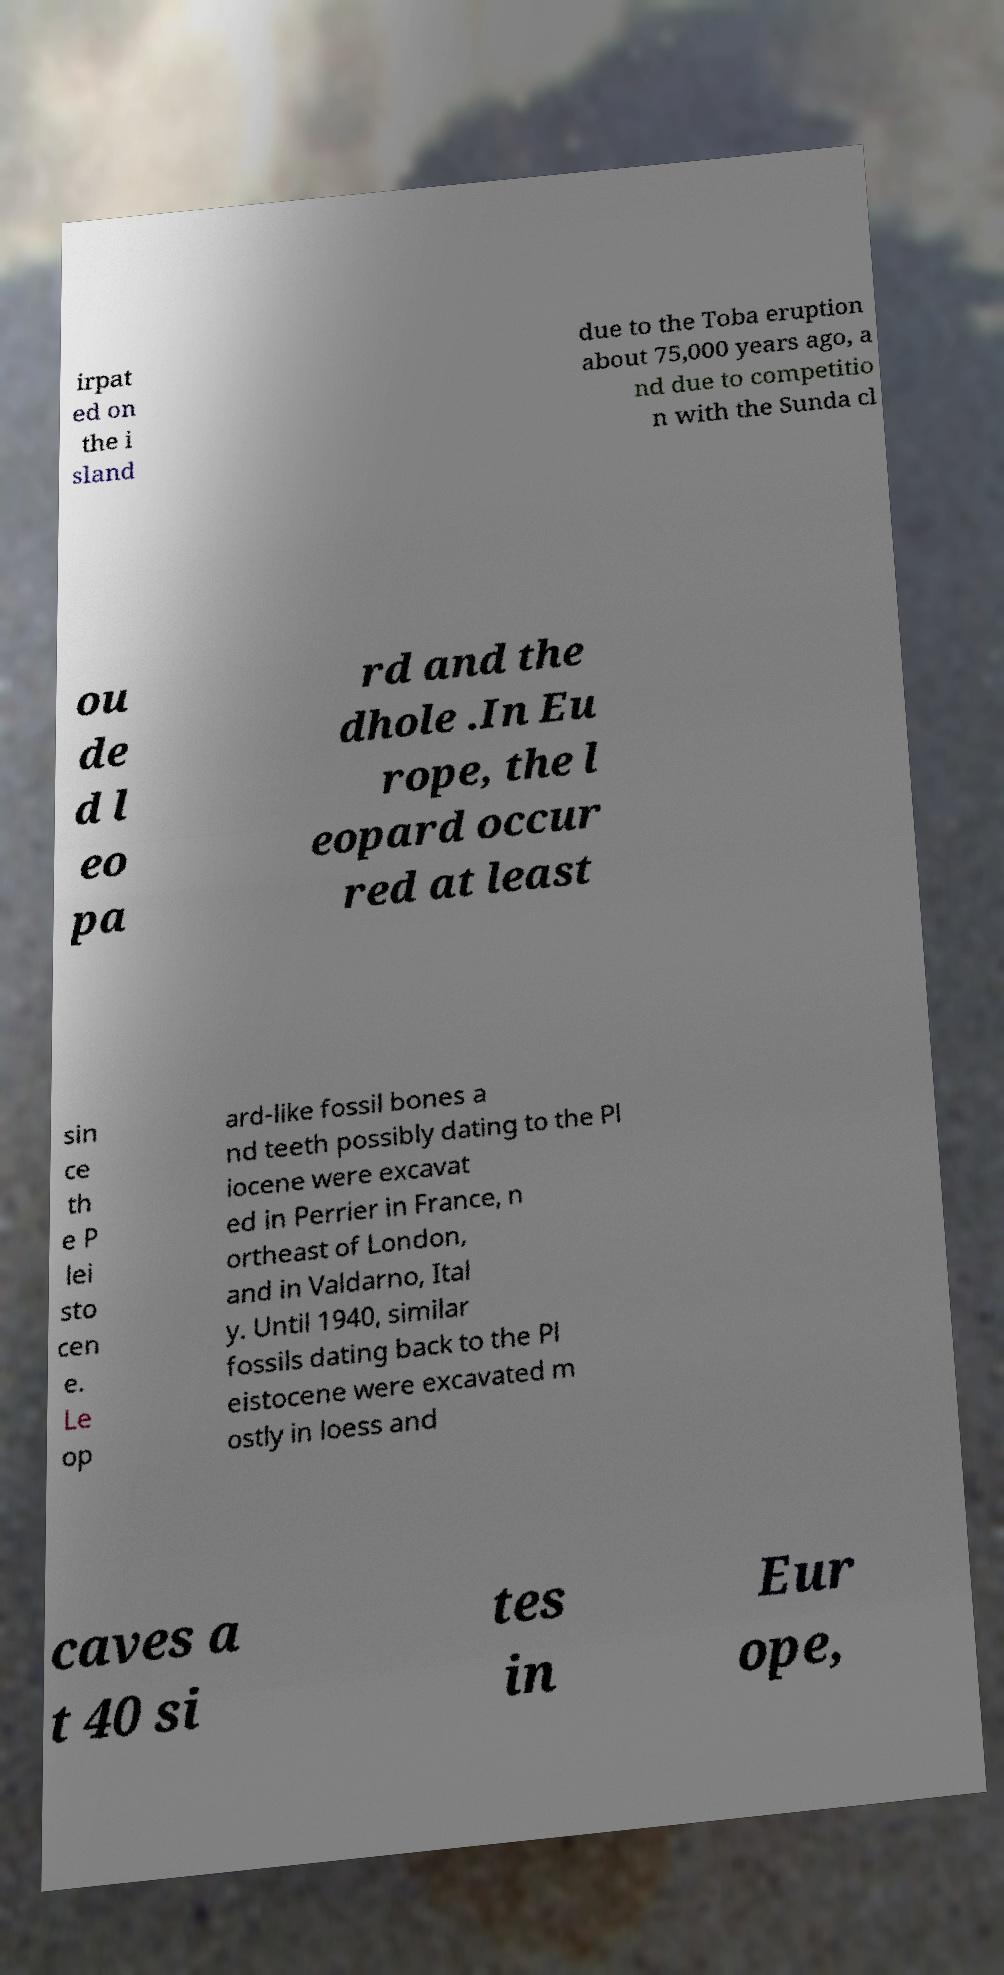Could you extract and type out the text from this image? irpat ed on the i sland due to the Toba eruption about 75,000 years ago, a nd due to competitio n with the Sunda cl ou de d l eo pa rd and the dhole .In Eu rope, the l eopard occur red at least sin ce th e P lei sto cen e. Le op ard-like fossil bones a nd teeth possibly dating to the Pl iocene were excavat ed in Perrier in France, n ortheast of London, and in Valdarno, Ital y. Until 1940, similar fossils dating back to the Pl eistocene were excavated m ostly in loess and caves a t 40 si tes in Eur ope, 